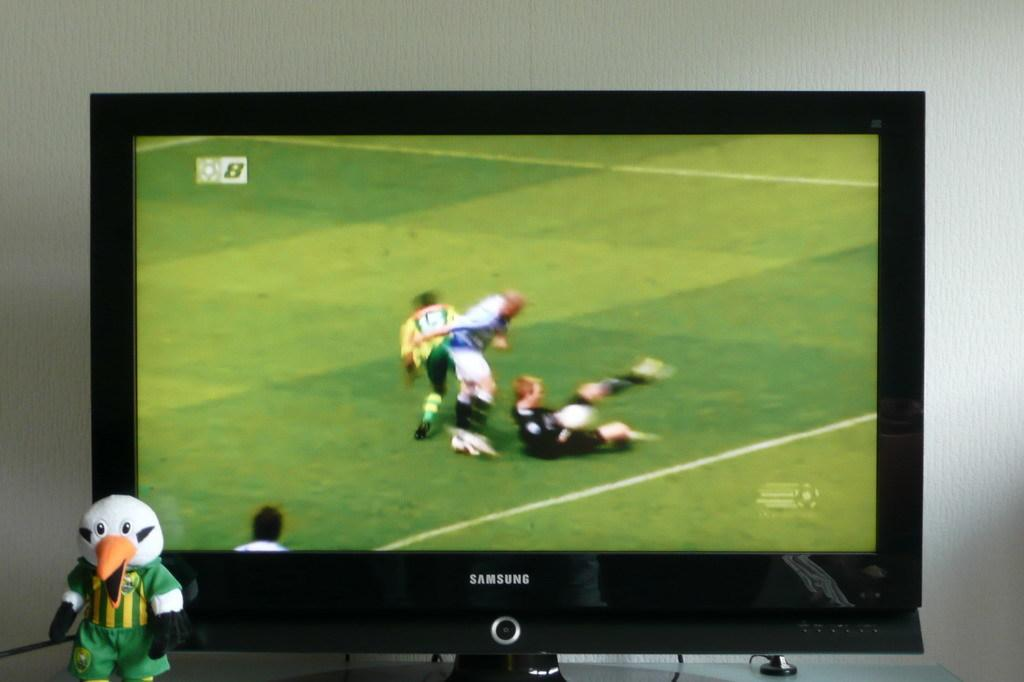Provide a one-sentence caption for the provided image. a television with the word samsung on the television. 